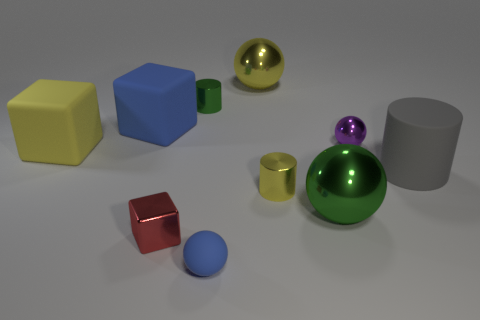Subtract 1 balls. How many balls are left? 3 Subtract all purple spheres. How many spheres are left? 3 Subtract all yellow spheres. How many spheres are left? 3 Subtract all red balls. Subtract all yellow cylinders. How many balls are left? 4 Subtract all cubes. How many objects are left? 7 Subtract 0 blue cylinders. How many objects are left? 10 Subtract all tiny yellow cylinders. Subtract all small green things. How many objects are left? 8 Add 6 small shiny blocks. How many small shiny blocks are left? 7 Add 3 large cyan cylinders. How many large cyan cylinders exist? 3 